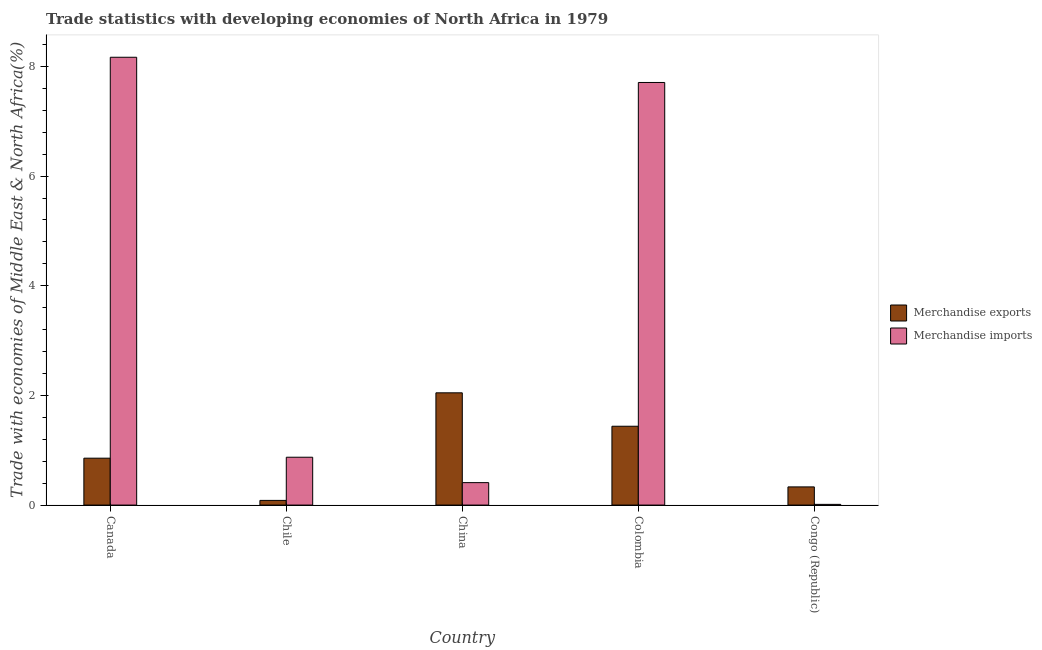What is the label of the 5th group of bars from the left?
Your answer should be very brief. Congo (Republic). What is the merchandise exports in Colombia?
Your response must be concise. 1.44. Across all countries, what is the maximum merchandise imports?
Give a very brief answer. 8.17. Across all countries, what is the minimum merchandise exports?
Provide a succinct answer. 0.09. In which country was the merchandise imports minimum?
Give a very brief answer. Congo (Republic). What is the total merchandise exports in the graph?
Offer a very short reply. 4.76. What is the difference between the merchandise imports in Canada and that in Colombia?
Offer a terse response. 0.46. What is the difference between the merchandise exports in China and the merchandise imports in Colombia?
Keep it short and to the point. -5.66. What is the average merchandise imports per country?
Keep it short and to the point. 3.43. What is the difference between the merchandise imports and merchandise exports in Canada?
Provide a succinct answer. 7.31. In how many countries, is the merchandise imports greater than 7.2 %?
Make the answer very short. 2. What is the ratio of the merchandise exports in Canada to that in China?
Provide a short and direct response. 0.42. Is the difference between the merchandise imports in Canada and Congo (Republic) greater than the difference between the merchandise exports in Canada and Congo (Republic)?
Make the answer very short. Yes. What is the difference between the highest and the second highest merchandise imports?
Give a very brief answer. 0.46. What is the difference between the highest and the lowest merchandise exports?
Your answer should be very brief. 1.96. In how many countries, is the merchandise exports greater than the average merchandise exports taken over all countries?
Keep it short and to the point. 2. Is the sum of the merchandise exports in China and Colombia greater than the maximum merchandise imports across all countries?
Offer a very short reply. No. What does the 1st bar from the right in China represents?
Your answer should be compact. Merchandise imports. How many bars are there?
Ensure brevity in your answer.  10. How many countries are there in the graph?
Offer a terse response. 5. Does the graph contain grids?
Provide a succinct answer. No. Where does the legend appear in the graph?
Offer a very short reply. Center right. What is the title of the graph?
Ensure brevity in your answer.  Trade statistics with developing economies of North Africa in 1979. What is the label or title of the Y-axis?
Keep it short and to the point. Trade with economies of Middle East & North Africa(%). What is the Trade with economies of Middle East & North Africa(%) of Merchandise exports in Canada?
Your response must be concise. 0.86. What is the Trade with economies of Middle East & North Africa(%) in Merchandise imports in Canada?
Offer a very short reply. 8.17. What is the Trade with economies of Middle East & North Africa(%) of Merchandise exports in Chile?
Give a very brief answer. 0.09. What is the Trade with economies of Middle East & North Africa(%) in Merchandise imports in Chile?
Give a very brief answer. 0.87. What is the Trade with economies of Middle East & North Africa(%) in Merchandise exports in China?
Provide a short and direct response. 2.05. What is the Trade with economies of Middle East & North Africa(%) in Merchandise imports in China?
Ensure brevity in your answer.  0.41. What is the Trade with economies of Middle East & North Africa(%) in Merchandise exports in Colombia?
Your response must be concise. 1.44. What is the Trade with economies of Middle East & North Africa(%) of Merchandise imports in Colombia?
Make the answer very short. 7.71. What is the Trade with economies of Middle East & North Africa(%) in Merchandise exports in Congo (Republic)?
Your answer should be compact. 0.33. What is the Trade with economies of Middle East & North Africa(%) in Merchandise imports in Congo (Republic)?
Keep it short and to the point. 0.01. Across all countries, what is the maximum Trade with economies of Middle East & North Africa(%) of Merchandise exports?
Your answer should be compact. 2.05. Across all countries, what is the maximum Trade with economies of Middle East & North Africa(%) of Merchandise imports?
Keep it short and to the point. 8.17. Across all countries, what is the minimum Trade with economies of Middle East & North Africa(%) of Merchandise exports?
Ensure brevity in your answer.  0.09. Across all countries, what is the minimum Trade with economies of Middle East & North Africa(%) of Merchandise imports?
Make the answer very short. 0.01. What is the total Trade with economies of Middle East & North Africa(%) of Merchandise exports in the graph?
Offer a terse response. 4.76. What is the total Trade with economies of Middle East & North Africa(%) in Merchandise imports in the graph?
Ensure brevity in your answer.  17.17. What is the difference between the Trade with economies of Middle East & North Africa(%) of Merchandise exports in Canada and that in Chile?
Your answer should be very brief. 0.77. What is the difference between the Trade with economies of Middle East & North Africa(%) in Merchandise imports in Canada and that in Chile?
Ensure brevity in your answer.  7.3. What is the difference between the Trade with economies of Middle East & North Africa(%) in Merchandise exports in Canada and that in China?
Provide a succinct answer. -1.19. What is the difference between the Trade with economies of Middle East & North Africa(%) in Merchandise imports in Canada and that in China?
Give a very brief answer. 7.76. What is the difference between the Trade with economies of Middle East & North Africa(%) in Merchandise exports in Canada and that in Colombia?
Offer a terse response. -0.58. What is the difference between the Trade with economies of Middle East & North Africa(%) of Merchandise imports in Canada and that in Colombia?
Make the answer very short. 0.46. What is the difference between the Trade with economies of Middle East & North Africa(%) in Merchandise exports in Canada and that in Congo (Republic)?
Your answer should be very brief. 0.52. What is the difference between the Trade with economies of Middle East & North Africa(%) of Merchandise imports in Canada and that in Congo (Republic)?
Make the answer very short. 8.16. What is the difference between the Trade with economies of Middle East & North Africa(%) in Merchandise exports in Chile and that in China?
Give a very brief answer. -1.96. What is the difference between the Trade with economies of Middle East & North Africa(%) of Merchandise imports in Chile and that in China?
Make the answer very short. 0.46. What is the difference between the Trade with economies of Middle East & North Africa(%) in Merchandise exports in Chile and that in Colombia?
Keep it short and to the point. -1.35. What is the difference between the Trade with economies of Middle East & North Africa(%) in Merchandise imports in Chile and that in Colombia?
Ensure brevity in your answer.  -6.84. What is the difference between the Trade with economies of Middle East & North Africa(%) of Merchandise exports in Chile and that in Congo (Republic)?
Your answer should be compact. -0.25. What is the difference between the Trade with economies of Middle East & North Africa(%) of Merchandise imports in Chile and that in Congo (Republic)?
Give a very brief answer. 0.86. What is the difference between the Trade with economies of Middle East & North Africa(%) in Merchandise exports in China and that in Colombia?
Offer a very short reply. 0.61. What is the difference between the Trade with economies of Middle East & North Africa(%) in Merchandise imports in China and that in Colombia?
Provide a short and direct response. -7.3. What is the difference between the Trade with economies of Middle East & North Africa(%) of Merchandise exports in China and that in Congo (Republic)?
Your answer should be very brief. 1.72. What is the difference between the Trade with economies of Middle East & North Africa(%) in Merchandise imports in China and that in Congo (Republic)?
Provide a succinct answer. 0.4. What is the difference between the Trade with economies of Middle East & North Africa(%) of Merchandise exports in Colombia and that in Congo (Republic)?
Provide a short and direct response. 1.11. What is the difference between the Trade with economies of Middle East & North Africa(%) of Merchandise imports in Colombia and that in Congo (Republic)?
Your answer should be very brief. 7.7. What is the difference between the Trade with economies of Middle East & North Africa(%) of Merchandise exports in Canada and the Trade with economies of Middle East & North Africa(%) of Merchandise imports in Chile?
Make the answer very short. -0.02. What is the difference between the Trade with economies of Middle East & North Africa(%) of Merchandise exports in Canada and the Trade with economies of Middle East & North Africa(%) of Merchandise imports in China?
Offer a terse response. 0.45. What is the difference between the Trade with economies of Middle East & North Africa(%) in Merchandise exports in Canada and the Trade with economies of Middle East & North Africa(%) in Merchandise imports in Colombia?
Give a very brief answer. -6.85. What is the difference between the Trade with economies of Middle East & North Africa(%) of Merchandise exports in Canada and the Trade with economies of Middle East & North Africa(%) of Merchandise imports in Congo (Republic)?
Provide a short and direct response. 0.84. What is the difference between the Trade with economies of Middle East & North Africa(%) of Merchandise exports in Chile and the Trade with economies of Middle East & North Africa(%) of Merchandise imports in China?
Your response must be concise. -0.32. What is the difference between the Trade with economies of Middle East & North Africa(%) of Merchandise exports in Chile and the Trade with economies of Middle East & North Africa(%) of Merchandise imports in Colombia?
Ensure brevity in your answer.  -7.62. What is the difference between the Trade with economies of Middle East & North Africa(%) in Merchandise exports in Chile and the Trade with economies of Middle East & North Africa(%) in Merchandise imports in Congo (Republic)?
Keep it short and to the point. 0.07. What is the difference between the Trade with economies of Middle East & North Africa(%) of Merchandise exports in China and the Trade with economies of Middle East & North Africa(%) of Merchandise imports in Colombia?
Keep it short and to the point. -5.66. What is the difference between the Trade with economies of Middle East & North Africa(%) in Merchandise exports in China and the Trade with economies of Middle East & North Africa(%) in Merchandise imports in Congo (Republic)?
Provide a succinct answer. 2.03. What is the difference between the Trade with economies of Middle East & North Africa(%) of Merchandise exports in Colombia and the Trade with economies of Middle East & North Africa(%) of Merchandise imports in Congo (Republic)?
Your response must be concise. 1.43. What is the average Trade with economies of Middle East & North Africa(%) of Merchandise exports per country?
Provide a short and direct response. 0.95. What is the average Trade with economies of Middle East & North Africa(%) of Merchandise imports per country?
Keep it short and to the point. 3.43. What is the difference between the Trade with economies of Middle East & North Africa(%) of Merchandise exports and Trade with economies of Middle East & North Africa(%) of Merchandise imports in Canada?
Make the answer very short. -7.31. What is the difference between the Trade with economies of Middle East & North Africa(%) of Merchandise exports and Trade with economies of Middle East & North Africa(%) of Merchandise imports in Chile?
Keep it short and to the point. -0.79. What is the difference between the Trade with economies of Middle East & North Africa(%) of Merchandise exports and Trade with economies of Middle East & North Africa(%) of Merchandise imports in China?
Provide a succinct answer. 1.64. What is the difference between the Trade with economies of Middle East & North Africa(%) of Merchandise exports and Trade with economies of Middle East & North Africa(%) of Merchandise imports in Colombia?
Keep it short and to the point. -6.27. What is the difference between the Trade with economies of Middle East & North Africa(%) in Merchandise exports and Trade with economies of Middle East & North Africa(%) in Merchandise imports in Congo (Republic)?
Give a very brief answer. 0.32. What is the ratio of the Trade with economies of Middle East & North Africa(%) in Merchandise exports in Canada to that in Chile?
Keep it short and to the point. 10.04. What is the ratio of the Trade with economies of Middle East & North Africa(%) of Merchandise imports in Canada to that in Chile?
Ensure brevity in your answer.  9.36. What is the ratio of the Trade with economies of Middle East & North Africa(%) of Merchandise exports in Canada to that in China?
Offer a terse response. 0.42. What is the ratio of the Trade with economies of Middle East & North Africa(%) in Merchandise imports in Canada to that in China?
Give a very brief answer. 19.95. What is the ratio of the Trade with economies of Middle East & North Africa(%) in Merchandise exports in Canada to that in Colombia?
Offer a very short reply. 0.59. What is the ratio of the Trade with economies of Middle East & North Africa(%) in Merchandise imports in Canada to that in Colombia?
Give a very brief answer. 1.06. What is the ratio of the Trade with economies of Middle East & North Africa(%) of Merchandise exports in Canada to that in Congo (Republic)?
Give a very brief answer. 2.58. What is the ratio of the Trade with economies of Middle East & North Africa(%) in Merchandise imports in Canada to that in Congo (Republic)?
Make the answer very short. 628.77. What is the ratio of the Trade with economies of Middle East & North Africa(%) of Merchandise exports in Chile to that in China?
Give a very brief answer. 0.04. What is the ratio of the Trade with economies of Middle East & North Africa(%) in Merchandise imports in Chile to that in China?
Give a very brief answer. 2.13. What is the ratio of the Trade with economies of Middle East & North Africa(%) of Merchandise exports in Chile to that in Colombia?
Provide a succinct answer. 0.06. What is the ratio of the Trade with economies of Middle East & North Africa(%) of Merchandise imports in Chile to that in Colombia?
Your answer should be very brief. 0.11. What is the ratio of the Trade with economies of Middle East & North Africa(%) in Merchandise exports in Chile to that in Congo (Republic)?
Offer a very short reply. 0.26. What is the ratio of the Trade with economies of Middle East & North Africa(%) of Merchandise imports in Chile to that in Congo (Republic)?
Make the answer very short. 67.18. What is the ratio of the Trade with economies of Middle East & North Africa(%) in Merchandise exports in China to that in Colombia?
Give a very brief answer. 1.42. What is the ratio of the Trade with economies of Middle East & North Africa(%) in Merchandise imports in China to that in Colombia?
Your answer should be very brief. 0.05. What is the ratio of the Trade with economies of Middle East & North Africa(%) in Merchandise exports in China to that in Congo (Republic)?
Your answer should be compact. 6.18. What is the ratio of the Trade with economies of Middle East & North Africa(%) in Merchandise imports in China to that in Congo (Republic)?
Offer a terse response. 31.52. What is the ratio of the Trade with economies of Middle East & North Africa(%) in Merchandise exports in Colombia to that in Congo (Republic)?
Provide a succinct answer. 4.34. What is the ratio of the Trade with economies of Middle East & North Africa(%) in Merchandise imports in Colombia to that in Congo (Republic)?
Keep it short and to the point. 593.37. What is the difference between the highest and the second highest Trade with economies of Middle East & North Africa(%) in Merchandise exports?
Provide a succinct answer. 0.61. What is the difference between the highest and the second highest Trade with economies of Middle East & North Africa(%) in Merchandise imports?
Give a very brief answer. 0.46. What is the difference between the highest and the lowest Trade with economies of Middle East & North Africa(%) of Merchandise exports?
Your answer should be very brief. 1.96. What is the difference between the highest and the lowest Trade with economies of Middle East & North Africa(%) in Merchandise imports?
Your answer should be very brief. 8.16. 